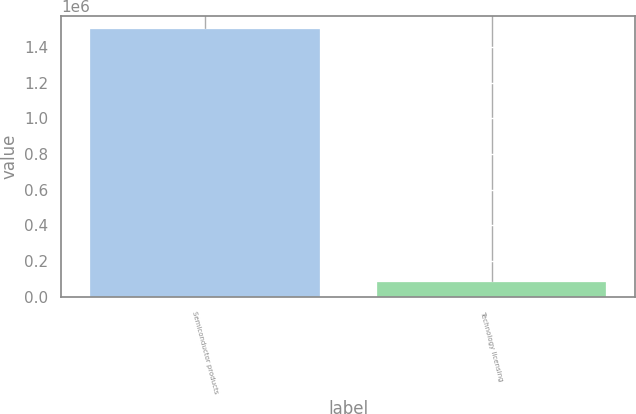<chart> <loc_0><loc_0><loc_500><loc_500><bar_chart><fcel>Semiconductor products<fcel>Technology licensing<nl><fcel>1.49782e+06<fcel>83803<nl></chart> 